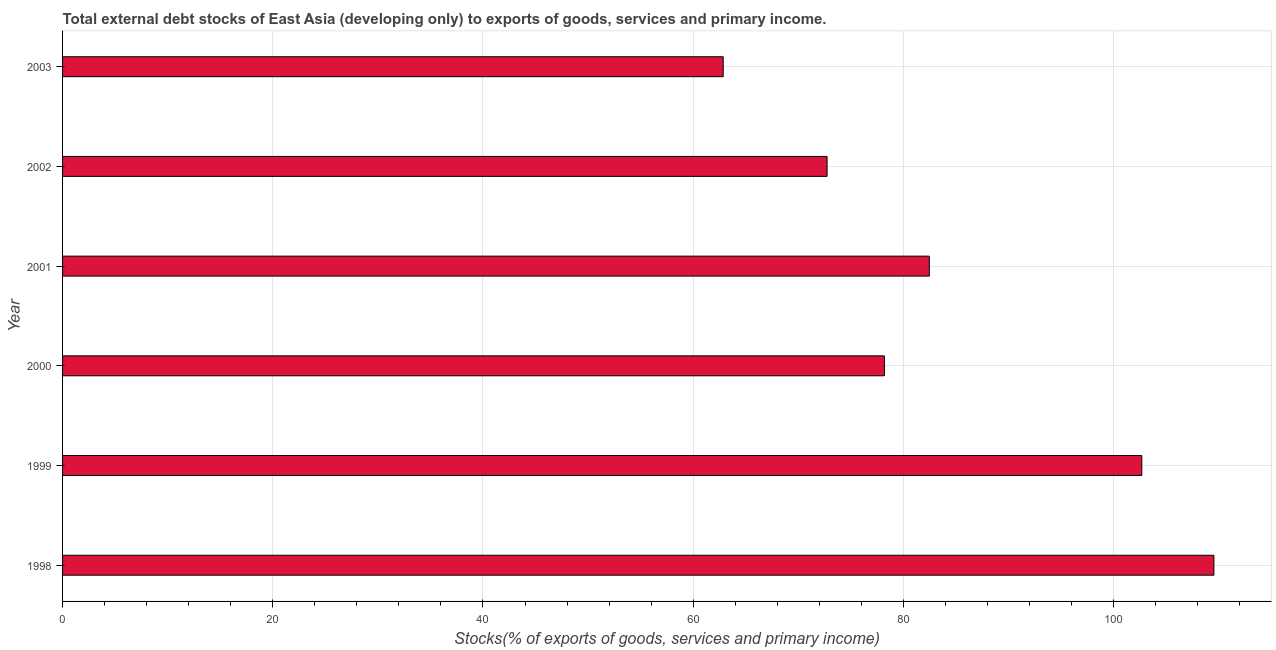Does the graph contain any zero values?
Your answer should be very brief. No. What is the title of the graph?
Your response must be concise. Total external debt stocks of East Asia (developing only) to exports of goods, services and primary income. What is the label or title of the X-axis?
Provide a short and direct response. Stocks(% of exports of goods, services and primary income). What is the external debt stocks in 1998?
Your answer should be very brief. 109.55. Across all years, what is the maximum external debt stocks?
Give a very brief answer. 109.55. Across all years, what is the minimum external debt stocks?
Provide a short and direct response. 62.86. What is the sum of the external debt stocks?
Your answer should be compact. 508.49. What is the difference between the external debt stocks in 1998 and 2003?
Offer a terse response. 46.69. What is the average external debt stocks per year?
Provide a succinct answer. 84.75. What is the median external debt stocks?
Make the answer very short. 80.33. In how many years, is the external debt stocks greater than 88 %?
Make the answer very short. 2. Do a majority of the years between 1999 and 2000 (inclusive) have external debt stocks greater than 68 %?
Your answer should be compact. Yes. What is the ratio of the external debt stocks in 1998 to that in 2002?
Offer a terse response. 1.51. What is the difference between the highest and the second highest external debt stocks?
Provide a succinct answer. 6.86. Is the sum of the external debt stocks in 1999 and 2003 greater than the maximum external debt stocks across all years?
Make the answer very short. Yes. What is the difference between the highest and the lowest external debt stocks?
Your answer should be very brief. 46.69. How many bars are there?
Ensure brevity in your answer.  6. How many years are there in the graph?
Give a very brief answer. 6. What is the Stocks(% of exports of goods, services and primary income) of 1998?
Your answer should be very brief. 109.55. What is the Stocks(% of exports of goods, services and primary income) of 1999?
Keep it short and to the point. 102.68. What is the Stocks(% of exports of goods, services and primary income) of 2000?
Keep it short and to the point. 78.2. What is the Stocks(% of exports of goods, services and primary income) of 2001?
Provide a succinct answer. 82.47. What is the Stocks(% of exports of goods, services and primary income) in 2002?
Ensure brevity in your answer.  72.74. What is the Stocks(% of exports of goods, services and primary income) of 2003?
Offer a very short reply. 62.86. What is the difference between the Stocks(% of exports of goods, services and primary income) in 1998 and 1999?
Provide a succinct answer. 6.86. What is the difference between the Stocks(% of exports of goods, services and primary income) in 1998 and 2000?
Your response must be concise. 31.35. What is the difference between the Stocks(% of exports of goods, services and primary income) in 1998 and 2001?
Provide a short and direct response. 27.08. What is the difference between the Stocks(% of exports of goods, services and primary income) in 1998 and 2002?
Offer a very short reply. 36.81. What is the difference between the Stocks(% of exports of goods, services and primary income) in 1998 and 2003?
Provide a succinct answer. 46.69. What is the difference between the Stocks(% of exports of goods, services and primary income) in 1999 and 2000?
Ensure brevity in your answer.  24.49. What is the difference between the Stocks(% of exports of goods, services and primary income) in 1999 and 2001?
Offer a very short reply. 20.22. What is the difference between the Stocks(% of exports of goods, services and primary income) in 1999 and 2002?
Your answer should be compact. 29.94. What is the difference between the Stocks(% of exports of goods, services and primary income) in 1999 and 2003?
Provide a short and direct response. 39.83. What is the difference between the Stocks(% of exports of goods, services and primary income) in 2000 and 2001?
Offer a terse response. -4.27. What is the difference between the Stocks(% of exports of goods, services and primary income) in 2000 and 2002?
Provide a short and direct response. 5.46. What is the difference between the Stocks(% of exports of goods, services and primary income) in 2000 and 2003?
Offer a very short reply. 15.34. What is the difference between the Stocks(% of exports of goods, services and primary income) in 2001 and 2002?
Offer a terse response. 9.73. What is the difference between the Stocks(% of exports of goods, services and primary income) in 2001 and 2003?
Provide a succinct answer. 19.61. What is the difference between the Stocks(% of exports of goods, services and primary income) in 2002 and 2003?
Provide a succinct answer. 9.88. What is the ratio of the Stocks(% of exports of goods, services and primary income) in 1998 to that in 1999?
Ensure brevity in your answer.  1.07. What is the ratio of the Stocks(% of exports of goods, services and primary income) in 1998 to that in 2000?
Provide a short and direct response. 1.4. What is the ratio of the Stocks(% of exports of goods, services and primary income) in 1998 to that in 2001?
Keep it short and to the point. 1.33. What is the ratio of the Stocks(% of exports of goods, services and primary income) in 1998 to that in 2002?
Ensure brevity in your answer.  1.51. What is the ratio of the Stocks(% of exports of goods, services and primary income) in 1998 to that in 2003?
Give a very brief answer. 1.74. What is the ratio of the Stocks(% of exports of goods, services and primary income) in 1999 to that in 2000?
Offer a terse response. 1.31. What is the ratio of the Stocks(% of exports of goods, services and primary income) in 1999 to that in 2001?
Your answer should be compact. 1.25. What is the ratio of the Stocks(% of exports of goods, services and primary income) in 1999 to that in 2002?
Your answer should be compact. 1.41. What is the ratio of the Stocks(% of exports of goods, services and primary income) in 1999 to that in 2003?
Offer a terse response. 1.63. What is the ratio of the Stocks(% of exports of goods, services and primary income) in 2000 to that in 2001?
Your response must be concise. 0.95. What is the ratio of the Stocks(% of exports of goods, services and primary income) in 2000 to that in 2002?
Provide a succinct answer. 1.07. What is the ratio of the Stocks(% of exports of goods, services and primary income) in 2000 to that in 2003?
Keep it short and to the point. 1.24. What is the ratio of the Stocks(% of exports of goods, services and primary income) in 2001 to that in 2002?
Your response must be concise. 1.13. What is the ratio of the Stocks(% of exports of goods, services and primary income) in 2001 to that in 2003?
Ensure brevity in your answer.  1.31. What is the ratio of the Stocks(% of exports of goods, services and primary income) in 2002 to that in 2003?
Offer a terse response. 1.16. 